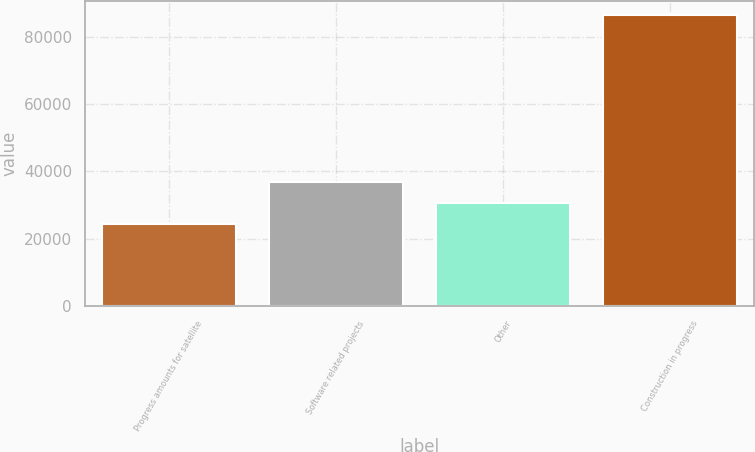<chart> <loc_0><loc_0><loc_500><loc_500><bar_chart><fcel>Progress amounts for satellite<fcel>Software related projects<fcel>Other<fcel>Construction in progress<nl><fcel>24303<fcel>36740.4<fcel>30521.7<fcel>86490<nl></chart> 